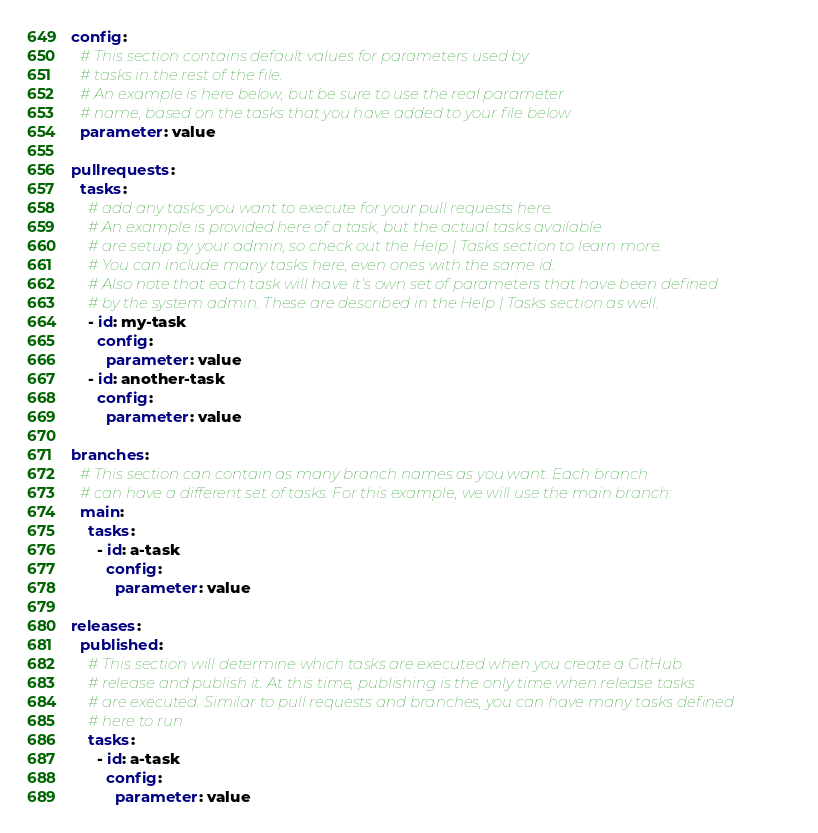<code> <loc_0><loc_0><loc_500><loc_500><_YAML_>config:
  # This section contains default values for parameters used by
  # tasks in the rest of the file.
  # An example is here below, but be sure to use the real parameter
  # name, based on the tasks that you have added to your file below
  parameter: value

pullrequests:
  tasks:
    # add any tasks you want to execute for your pull requests here.
    # An example is provided here of a task, but the actual tasks available
    # are setup by your admin, so check out the Help | Tasks section to learn more.
    # You can include many tasks here, even ones with the same id.
    # Also note that each task will have it's own set of parameters that have been defined
    # by the system admin. These are described in the Help | Tasks section as well.
    - id: my-task
      config:
        parameter: value
    - id: another-task
      config:
        parameter: value

branches:
  # This section can contain as many branch names as you want. Each branch
  # can have a different set of tasks. For this example, we will use the main branch:
  main:
    tasks:
      - id: a-task
        config:
          parameter: value

releases:
  published:
    # This section will determine which tasks are executed when you create a GitHub
    # release and publish it. At this time, publishing is the only time when release tasks
    # are executed. Similar to pull requests and branches, you can have many tasks defined
    # here to run
    tasks:
      - id: a-task
        config:
          parameter: value
</code> 